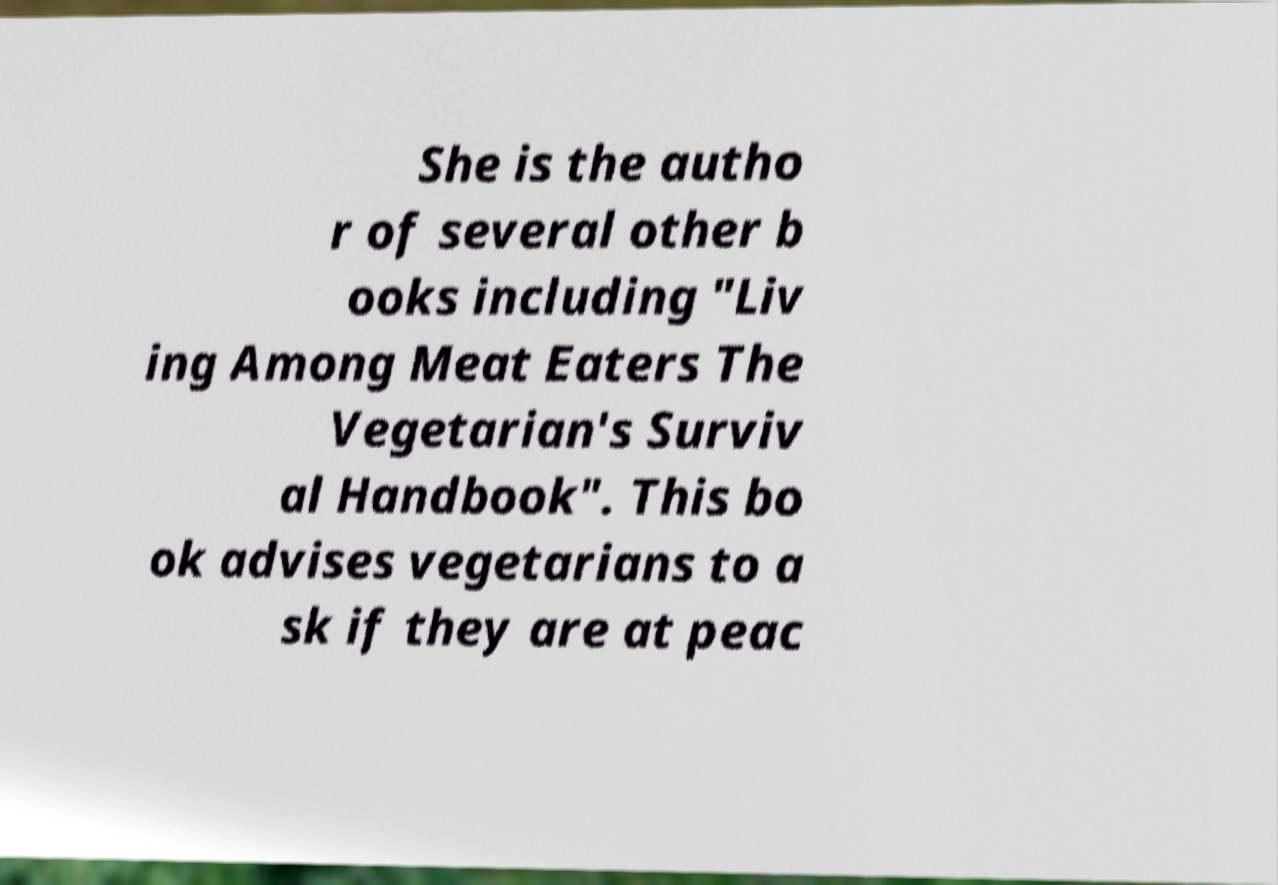Can you accurately transcribe the text from the provided image for me? She is the autho r of several other b ooks including "Liv ing Among Meat Eaters The Vegetarian's Surviv al Handbook". This bo ok advises vegetarians to a sk if they are at peac 